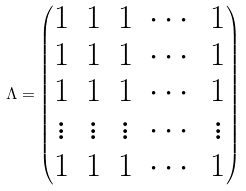Convert formula to latex. <formula><loc_0><loc_0><loc_500><loc_500>\Lambda = \begin{pmatrix} 1 & 1 & 1 & \cdots & 1 \\ 1 & 1 & 1 & \cdots & 1 \\ 1 & 1 & 1 & \cdots & 1 \\ \vdots & \vdots & \vdots & \cdots & \vdots \\ 1 & 1 & 1 & \cdots & 1 \end{pmatrix}</formula> 